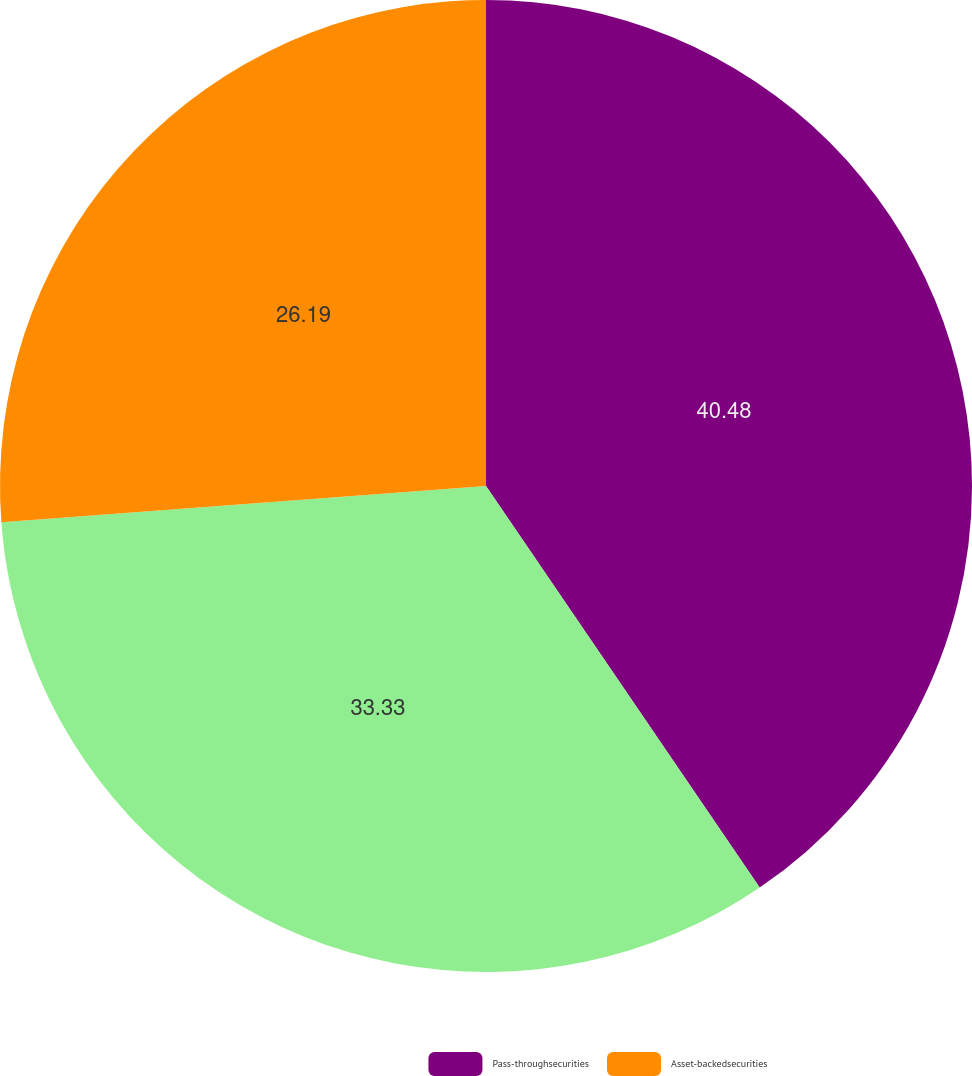Convert chart. <chart><loc_0><loc_0><loc_500><loc_500><pie_chart><fcel>Pass-throughsecurities<fcel>Unnamed: 1<fcel>Asset-backedsecurities<nl><fcel>40.48%<fcel>33.33%<fcel>26.19%<nl></chart> 